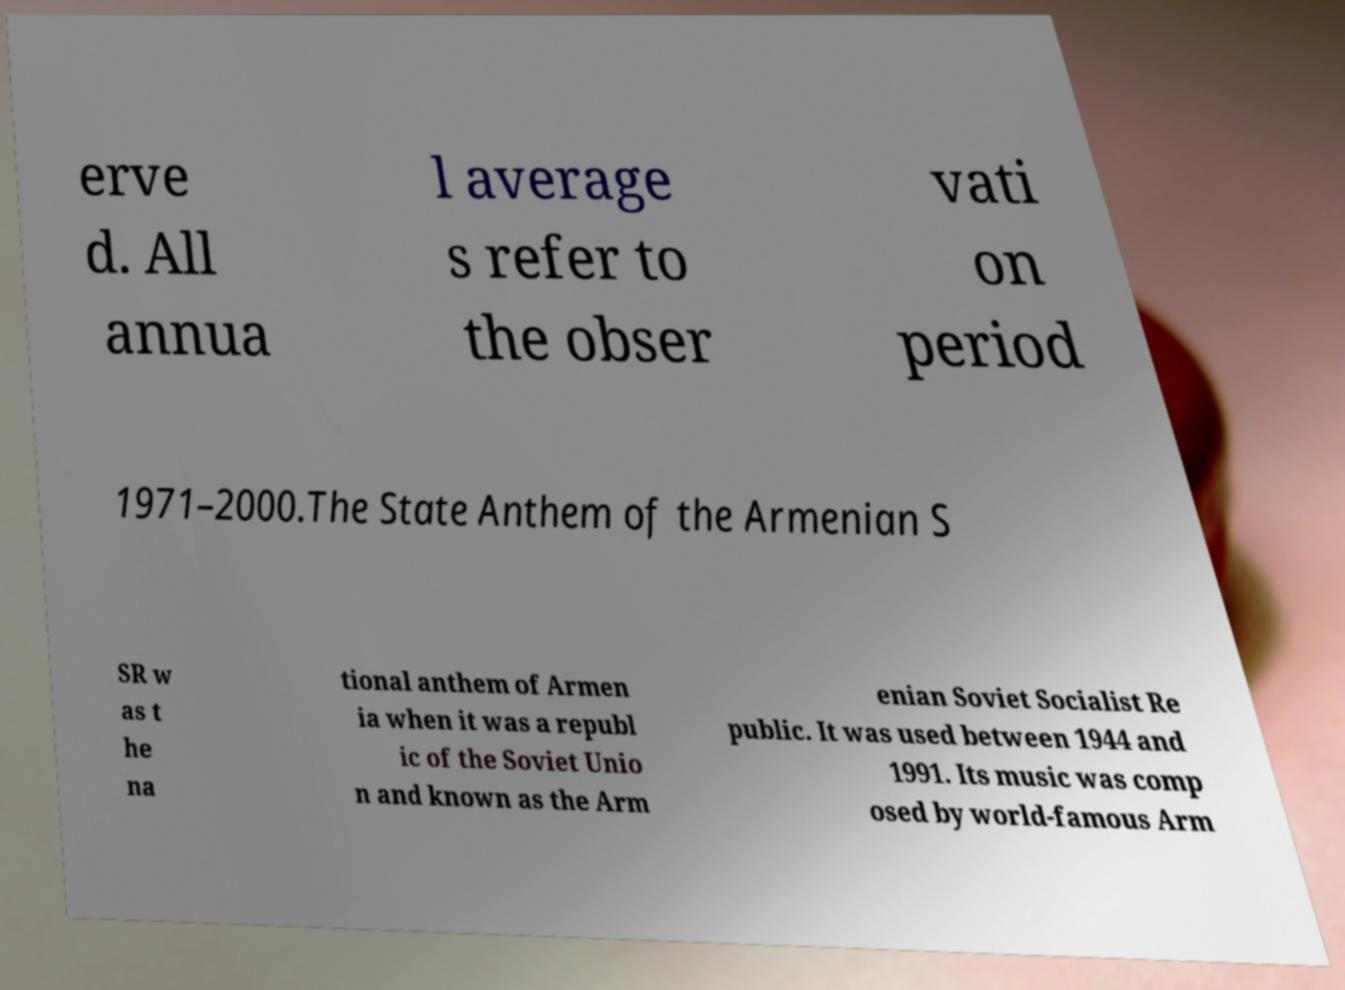For documentation purposes, I need the text within this image transcribed. Could you provide that? erve d. All annua l average s refer to the obser vati on period 1971–2000.The State Anthem of the Armenian S SR w as t he na tional anthem of Armen ia when it was a republ ic of the Soviet Unio n and known as the Arm enian Soviet Socialist Re public. It was used between 1944 and 1991. Its music was comp osed by world-famous Arm 